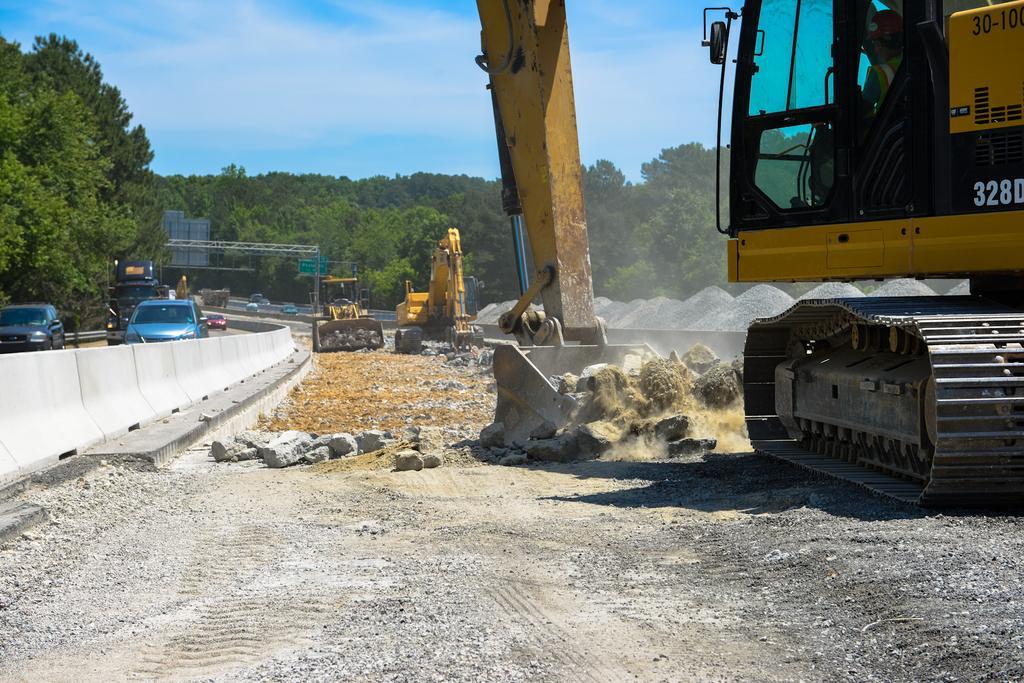Could you give a brief overview of what you see in this image? In the image we can see some excavators and vehicles on the road. Behind them there are some trees and poles and sign boards. At the top of the image there are some clouds and sky. 